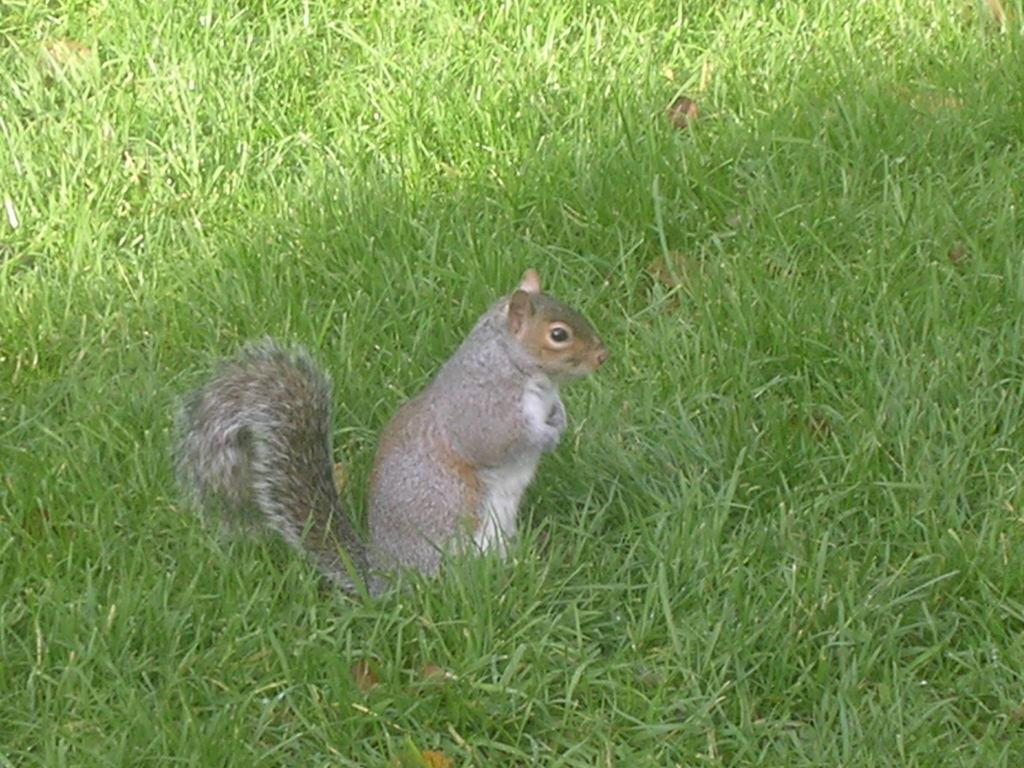What type of vegetation is present in the image? There is grass in the image. What type of animal can be seen in the image? There is a squirrel in the image. What type of thing is the grandfather holding in the image? There is no grandfather present in the image, so it is not possible to answer that question. 